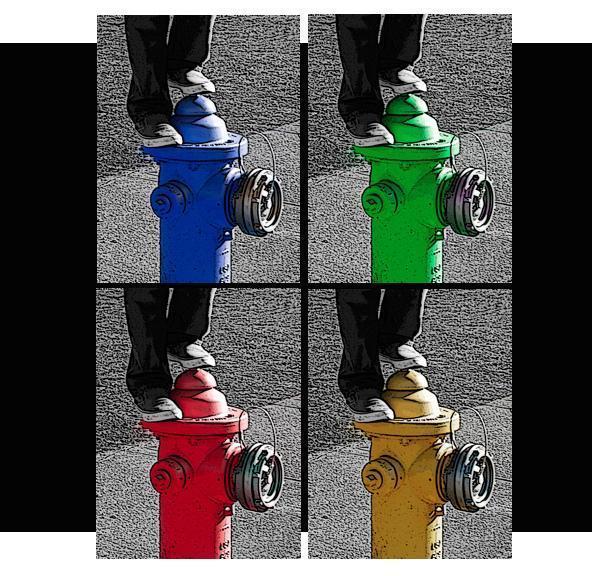How many different colors are the hydrants?
Give a very brief answer. 4. How many people are there?
Give a very brief answer. 4. How many fire hydrants are there?
Give a very brief answer. 4. 